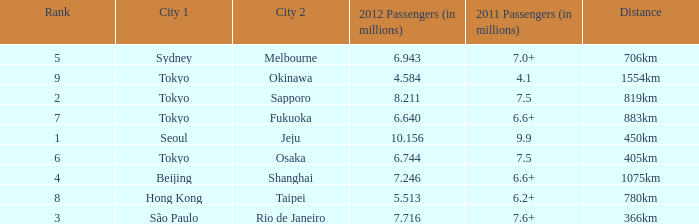How many passengers (in millions) flew from Seoul in 2012? 10.156. 